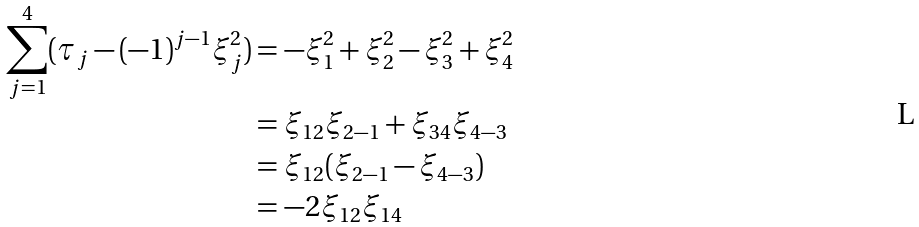Convert formula to latex. <formula><loc_0><loc_0><loc_500><loc_500>\sum _ { j = 1 } ^ { 4 } ( \tau _ { j } - ( - 1 ) ^ { j - 1 } \xi ^ { 2 } _ { j } ) & = - \xi _ { 1 } ^ { 2 } + \xi _ { 2 } ^ { 2 } - \xi _ { 3 } ^ { 2 } + \xi _ { 4 } ^ { 2 } \\ & = \xi _ { 1 2 } \xi _ { 2 - 1 } + \xi _ { 3 4 } \xi _ { 4 - 3 } \\ & = \xi _ { 1 2 } ( \xi _ { 2 - 1 } - \xi _ { 4 - 3 } ) \\ & = - 2 \xi _ { 1 2 } \xi _ { 1 4 }</formula> 